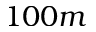Convert formula to latex. <formula><loc_0><loc_0><loc_500><loc_500>1 0 0 m</formula> 